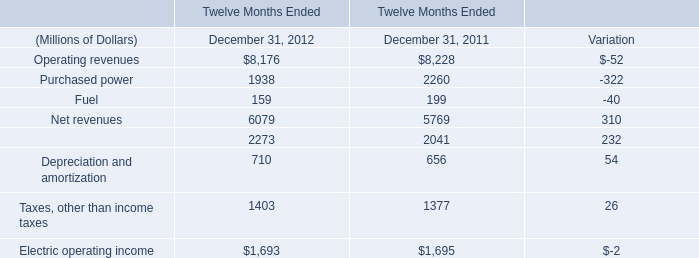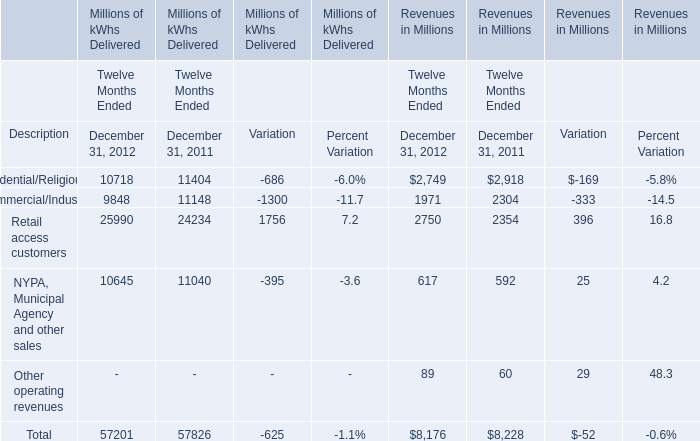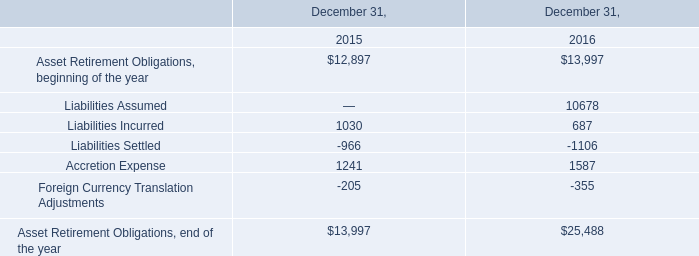What was the total amount of Twelve Months Ended greater than 1000 for December 31, 2012? (in million) 
Computations: (((((8176 + 1938) + 6079) + 2273) + 1403) + 1693)
Answer: 21562.0. 